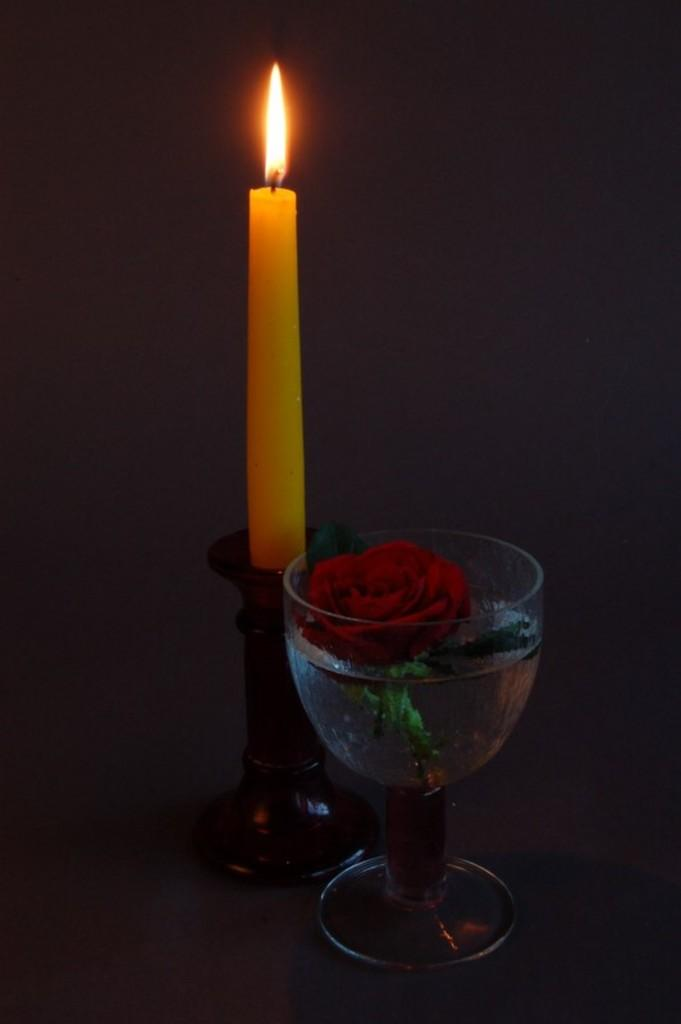What can be seen burning in the image? There is a lighted candle in the image. What is the candle placed on? The candle is placed on an object. What is in the glass that is visible in the image? There is a glass of water in the image, and a rose is placed in the glass of water. What type of education is being offered in the image? There is no indication of any educational activity in the image; it features a lighted candle, a glass of water with a rose, and an unspecified object. What color are the trousers being worn by the person in the image? There is no person present in the image, so it is not possible to determine what they might be wearing. 